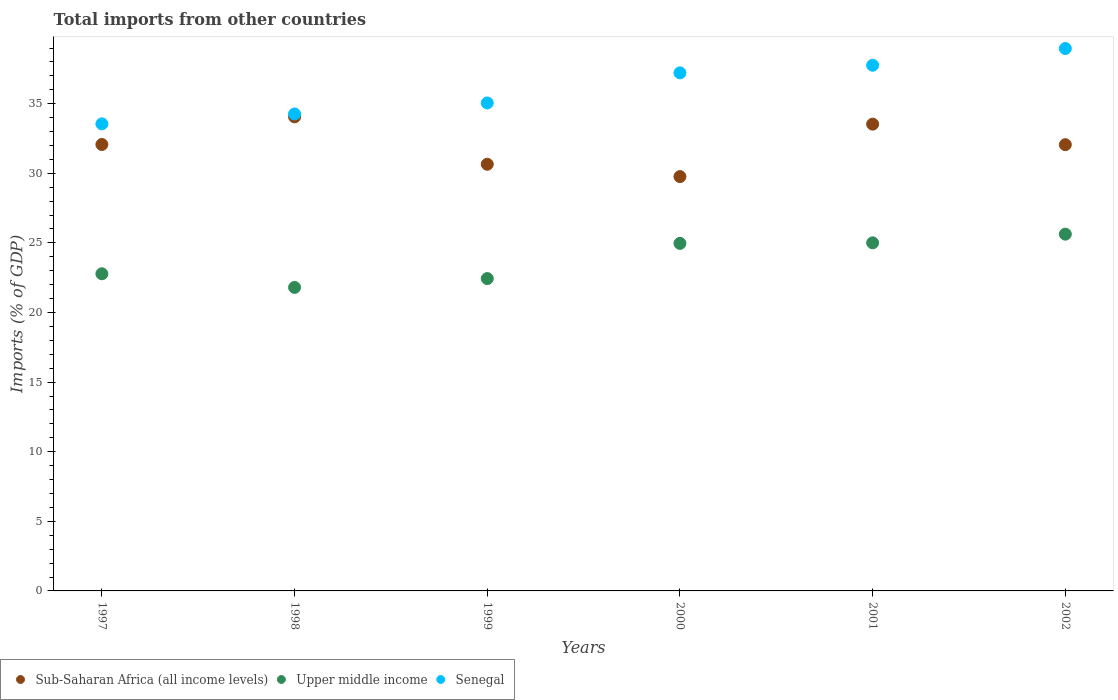How many different coloured dotlines are there?
Offer a terse response. 3. What is the total imports in Upper middle income in 1999?
Your response must be concise. 22.44. Across all years, what is the maximum total imports in Senegal?
Make the answer very short. 38.97. Across all years, what is the minimum total imports in Sub-Saharan Africa (all income levels)?
Provide a succinct answer. 29.77. In which year was the total imports in Senegal maximum?
Your response must be concise. 2002. In which year was the total imports in Upper middle income minimum?
Provide a short and direct response. 1998. What is the total total imports in Senegal in the graph?
Your answer should be very brief. 216.81. What is the difference between the total imports in Senegal in 1999 and that in 2001?
Your answer should be very brief. -2.71. What is the difference between the total imports in Upper middle income in 1998 and the total imports in Sub-Saharan Africa (all income levels) in 1999?
Keep it short and to the point. -8.85. What is the average total imports in Senegal per year?
Give a very brief answer. 36.14. In the year 2000, what is the difference between the total imports in Upper middle income and total imports in Sub-Saharan Africa (all income levels)?
Give a very brief answer. -4.8. What is the ratio of the total imports in Upper middle income in 1997 to that in 2000?
Offer a very short reply. 0.91. Is the difference between the total imports in Upper middle income in 2000 and 2001 greater than the difference between the total imports in Sub-Saharan Africa (all income levels) in 2000 and 2001?
Provide a short and direct response. Yes. What is the difference between the highest and the second highest total imports in Sub-Saharan Africa (all income levels)?
Provide a short and direct response. 0.52. What is the difference between the highest and the lowest total imports in Sub-Saharan Africa (all income levels)?
Make the answer very short. 4.29. Is it the case that in every year, the sum of the total imports in Senegal and total imports in Upper middle income  is greater than the total imports in Sub-Saharan Africa (all income levels)?
Keep it short and to the point. Yes. Does the total imports in Sub-Saharan Africa (all income levels) monotonically increase over the years?
Give a very brief answer. No. How many years are there in the graph?
Your response must be concise. 6. What is the difference between two consecutive major ticks on the Y-axis?
Your answer should be very brief. 5. How many legend labels are there?
Provide a succinct answer. 3. How are the legend labels stacked?
Your response must be concise. Horizontal. What is the title of the graph?
Give a very brief answer. Total imports from other countries. What is the label or title of the Y-axis?
Keep it short and to the point. Imports (% of GDP). What is the Imports (% of GDP) of Sub-Saharan Africa (all income levels) in 1997?
Your answer should be compact. 32.07. What is the Imports (% of GDP) in Upper middle income in 1997?
Give a very brief answer. 22.78. What is the Imports (% of GDP) of Senegal in 1997?
Make the answer very short. 33.55. What is the Imports (% of GDP) of Sub-Saharan Africa (all income levels) in 1998?
Your answer should be very brief. 34.06. What is the Imports (% of GDP) in Upper middle income in 1998?
Ensure brevity in your answer.  21.8. What is the Imports (% of GDP) in Senegal in 1998?
Offer a terse response. 34.26. What is the Imports (% of GDP) of Sub-Saharan Africa (all income levels) in 1999?
Keep it short and to the point. 30.65. What is the Imports (% of GDP) in Upper middle income in 1999?
Keep it short and to the point. 22.44. What is the Imports (% of GDP) in Senegal in 1999?
Provide a succinct answer. 35.05. What is the Imports (% of GDP) of Sub-Saharan Africa (all income levels) in 2000?
Your answer should be very brief. 29.77. What is the Imports (% of GDP) in Upper middle income in 2000?
Provide a short and direct response. 24.97. What is the Imports (% of GDP) of Senegal in 2000?
Give a very brief answer. 37.22. What is the Imports (% of GDP) of Sub-Saharan Africa (all income levels) in 2001?
Offer a terse response. 33.53. What is the Imports (% of GDP) in Upper middle income in 2001?
Offer a very short reply. 25.01. What is the Imports (% of GDP) in Senegal in 2001?
Provide a succinct answer. 37.76. What is the Imports (% of GDP) in Sub-Saharan Africa (all income levels) in 2002?
Keep it short and to the point. 32.06. What is the Imports (% of GDP) in Upper middle income in 2002?
Make the answer very short. 25.63. What is the Imports (% of GDP) in Senegal in 2002?
Make the answer very short. 38.97. Across all years, what is the maximum Imports (% of GDP) of Sub-Saharan Africa (all income levels)?
Offer a very short reply. 34.06. Across all years, what is the maximum Imports (% of GDP) of Upper middle income?
Provide a short and direct response. 25.63. Across all years, what is the maximum Imports (% of GDP) in Senegal?
Provide a short and direct response. 38.97. Across all years, what is the minimum Imports (% of GDP) in Sub-Saharan Africa (all income levels)?
Keep it short and to the point. 29.77. Across all years, what is the minimum Imports (% of GDP) of Upper middle income?
Provide a succinct answer. 21.8. Across all years, what is the minimum Imports (% of GDP) of Senegal?
Provide a short and direct response. 33.55. What is the total Imports (% of GDP) of Sub-Saharan Africa (all income levels) in the graph?
Provide a succinct answer. 192.13. What is the total Imports (% of GDP) of Upper middle income in the graph?
Offer a very short reply. 142.63. What is the total Imports (% of GDP) of Senegal in the graph?
Your response must be concise. 216.81. What is the difference between the Imports (% of GDP) of Sub-Saharan Africa (all income levels) in 1997 and that in 1998?
Ensure brevity in your answer.  -1.98. What is the difference between the Imports (% of GDP) of Upper middle income in 1997 and that in 1998?
Offer a terse response. 0.98. What is the difference between the Imports (% of GDP) of Senegal in 1997 and that in 1998?
Give a very brief answer. -0.71. What is the difference between the Imports (% of GDP) in Sub-Saharan Africa (all income levels) in 1997 and that in 1999?
Your answer should be compact. 1.42. What is the difference between the Imports (% of GDP) of Upper middle income in 1997 and that in 1999?
Offer a terse response. 0.35. What is the difference between the Imports (% of GDP) in Senegal in 1997 and that in 1999?
Offer a very short reply. -1.5. What is the difference between the Imports (% of GDP) of Sub-Saharan Africa (all income levels) in 1997 and that in 2000?
Offer a terse response. 2.31. What is the difference between the Imports (% of GDP) of Upper middle income in 1997 and that in 2000?
Your answer should be very brief. -2.18. What is the difference between the Imports (% of GDP) of Senegal in 1997 and that in 2000?
Your answer should be very brief. -3.66. What is the difference between the Imports (% of GDP) in Sub-Saharan Africa (all income levels) in 1997 and that in 2001?
Your answer should be compact. -1.46. What is the difference between the Imports (% of GDP) of Upper middle income in 1997 and that in 2001?
Offer a very short reply. -2.22. What is the difference between the Imports (% of GDP) in Senegal in 1997 and that in 2001?
Keep it short and to the point. -4.21. What is the difference between the Imports (% of GDP) in Sub-Saharan Africa (all income levels) in 1997 and that in 2002?
Keep it short and to the point. 0.01. What is the difference between the Imports (% of GDP) of Upper middle income in 1997 and that in 2002?
Ensure brevity in your answer.  -2.85. What is the difference between the Imports (% of GDP) in Senegal in 1997 and that in 2002?
Your answer should be compact. -5.41. What is the difference between the Imports (% of GDP) of Sub-Saharan Africa (all income levels) in 1998 and that in 1999?
Keep it short and to the point. 3.4. What is the difference between the Imports (% of GDP) of Upper middle income in 1998 and that in 1999?
Your response must be concise. -0.64. What is the difference between the Imports (% of GDP) of Senegal in 1998 and that in 1999?
Make the answer very short. -0.79. What is the difference between the Imports (% of GDP) of Sub-Saharan Africa (all income levels) in 1998 and that in 2000?
Make the answer very short. 4.29. What is the difference between the Imports (% of GDP) of Upper middle income in 1998 and that in 2000?
Provide a succinct answer. -3.16. What is the difference between the Imports (% of GDP) of Senegal in 1998 and that in 2000?
Provide a short and direct response. -2.95. What is the difference between the Imports (% of GDP) of Sub-Saharan Africa (all income levels) in 1998 and that in 2001?
Your answer should be compact. 0.52. What is the difference between the Imports (% of GDP) of Upper middle income in 1998 and that in 2001?
Provide a succinct answer. -3.2. What is the difference between the Imports (% of GDP) of Senegal in 1998 and that in 2001?
Offer a very short reply. -3.5. What is the difference between the Imports (% of GDP) in Sub-Saharan Africa (all income levels) in 1998 and that in 2002?
Your answer should be very brief. 2. What is the difference between the Imports (% of GDP) in Upper middle income in 1998 and that in 2002?
Give a very brief answer. -3.83. What is the difference between the Imports (% of GDP) of Senegal in 1998 and that in 2002?
Provide a short and direct response. -4.7. What is the difference between the Imports (% of GDP) in Sub-Saharan Africa (all income levels) in 1999 and that in 2000?
Give a very brief answer. 0.89. What is the difference between the Imports (% of GDP) in Upper middle income in 1999 and that in 2000?
Offer a very short reply. -2.53. What is the difference between the Imports (% of GDP) in Senegal in 1999 and that in 2000?
Ensure brevity in your answer.  -2.16. What is the difference between the Imports (% of GDP) in Sub-Saharan Africa (all income levels) in 1999 and that in 2001?
Your response must be concise. -2.88. What is the difference between the Imports (% of GDP) in Upper middle income in 1999 and that in 2001?
Give a very brief answer. -2.57. What is the difference between the Imports (% of GDP) in Senegal in 1999 and that in 2001?
Provide a succinct answer. -2.71. What is the difference between the Imports (% of GDP) in Sub-Saharan Africa (all income levels) in 1999 and that in 2002?
Offer a terse response. -1.41. What is the difference between the Imports (% of GDP) in Upper middle income in 1999 and that in 2002?
Your answer should be very brief. -3.19. What is the difference between the Imports (% of GDP) of Senegal in 1999 and that in 2002?
Your answer should be compact. -3.91. What is the difference between the Imports (% of GDP) of Sub-Saharan Africa (all income levels) in 2000 and that in 2001?
Make the answer very short. -3.77. What is the difference between the Imports (% of GDP) of Upper middle income in 2000 and that in 2001?
Keep it short and to the point. -0.04. What is the difference between the Imports (% of GDP) in Senegal in 2000 and that in 2001?
Provide a short and direct response. -0.55. What is the difference between the Imports (% of GDP) in Sub-Saharan Africa (all income levels) in 2000 and that in 2002?
Your answer should be very brief. -2.29. What is the difference between the Imports (% of GDP) of Upper middle income in 2000 and that in 2002?
Provide a succinct answer. -0.66. What is the difference between the Imports (% of GDP) in Senegal in 2000 and that in 2002?
Ensure brevity in your answer.  -1.75. What is the difference between the Imports (% of GDP) of Sub-Saharan Africa (all income levels) in 2001 and that in 2002?
Keep it short and to the point. 1.48. What is the difference between the Imports (% of GDP) of Upper middle income in 2001 and that in 2002?
Give a very brief answer. -0.62. What is the difference between the Imports (% of GDP) of Senegal in 2001 and that in 2002?
Your answer should be very brief. -1.2. What is the difference between the Imports (% of GDP) of Sub-Saharan Africa (all income levels) in 1997 and the Imports (% of GDP) of Upper middle income in 1998?
Make the answer very short. 10.27. What is the difference between the Imports (% of GDP) in Sub-Saharan Africa (all income levels) in 1997 and the Imports (% of GDP) in Senegal in 1998?
Ensure brevity in your answer.  -2.19. What is the difference between the Imports (% of GDP) of Upper middle income in 1997 and the Imports (% of GDP) of Senegal in 1998?
Your response must be concise. -11.48. What is the difference between the Imports (% of GDP) of Sub-Saharan Africa (all income levels) in 1997 and the Imports (% of GDP) of Upper middle income in 1999?
Keep it short and to the point. 9.63. What is the difference between the Imports (% of GDP) in Sub-Saharan Africa (all income levels) in 1997 and the Imports (% of GDP) in Senegal in 1999?
Offer a very short reply. -2.98. What is the difference between the Imports (% of GDP) in Upper middle income in 1997 and the Imports (% of GDP) in Senegal in 1999?
Your response must be concise. -12.27. What is the difference between the Imports (% of GDP) in Sub-Saharan Africa (all income levels) in 1997 and the Imports (% of GDP) in Upper middle income in 2000?
Make the answer very short. 7.11. What is the difference between the Imports (% of GDP) of Sub-Saharan Africa (all income levels) in 1997 and the Imports (% of GDP) of Senegal in 2000?
Give a very brief answer. -5.15. What is the difference between the Imports (% of GDP) of Upper middle income in 1997 and the Imports (% of GDP) of Senegal in 2000?
Your answer should be very brief. -14.43. What is the difference between the Imports (% of GDP) in Sub-Saharan Africa (all income levels) in 1997 and the Imports (% of GDP) in Upper middle income in 2001?
Provide a succinct answer. 7.07. What is the difference between the Imports (% of GDP) in Sub-Saharan Africa (all income levels) in 1997 and the Imports (% of GDP) in Senegal in 2001?
Your answer should be very brief. -5.69. What is the difference between the Imports (% of GDP) of Upper middle income in 1997 and the Imports (% of GDP) of Senegal in 2001?
Make the answer very short. -14.98. What is the difference between the Imports (% of GDP) in Sub-Saharan Africa (all income levels) in 1997 and the Imports (% of GDP) in Upper middle income in 2002?
Your response must be concise. 6.44. What is the difference between the Imports (% of GDP) of Sub-Saharan Africa (all income levels) in 1997 and the Imports (% of GDP) of Senegal in 2002?
Offer a terse response. -6.89. What is the difference between the Imports (% of GDP) in Upper middle income in 1997 and the Imports (% of GDP) in Senegal in 2002?
Your answer should be compact. -16.18. What is the difference between the Imports (% of GDP) of Sub-Saharan Africa (all income levels) in 1998 and the Imports (% of GDP) of Upper middle income in 1999?
Provide a succinct answer. 11.62. What is the difference between the Imports (% of GDP) of Sub-Saharan Africa (all income levels) in 1998 and the Imports (% of GDP) of Senegal in 1999?
Make the answer very short. -1. What is the difference between the Imports (% of GDP) of Upper middle income in 1998 and the Imports (% of GDP) of Senegal in 1999?
Keep it short and to the point. -13.25. What is the difference between the Imports (% of GDP) of Sub-Saharan Africa (all income levels) in 1998 and the Imports (% of GDP) of Upper middle income in 2000?
Your answer should be compact. 9.09. What is the difference between the Imports (% of GDP) of Sub-Saharan Africa (all income levels) in 1998 and the Imports (% of GDP) of Senegal in 2000?
Ensure brevity in your answer.  -3.16. What is the difference between the Imports (% of GDP) of Upper middle income in 1998 and the Imports (% of GDP) of Senegal in 2000?
Your response must be concise. -15.41. What is the difference between the Imports (% of GDP) of Sub-Saharan Africa (all income levels) in 1998 and the Imports (% of GDP) of Upper middle income in 2001?
Your answer should be very brief. 9.05. What is the difference between the Imports (% of GDP) of Sub-Saharan Africa (all income levels) in 1998 and the Imports (% of GDP) of Senegal in 2001?
Keep it short and to the point. -3.71. What is the difference between the Imports (% of GDP) of Upper middle income in 1998 and the Imports (% of GDP) of Senegal in 2001?
Your answer should be compact. -15.96. What is the difference between the Imports (% of GDP) in Sub-Saharan Africa (all income levels) in 1998 and the Imports (% of GDP) in Upper middle income in 2002?
Provide a short and direct response. 8.43. What is the difference between the Imports (% of GDP) of Sub-Saharan Africa (all income levels) in 1998 and the Imports (% of GDP) of Senegal in 2002?
Keep it short and to the point. -4.91. What is the difference between the Imports (% of GDP) of Upper middle income in 1998 and the Imports (% of GDP) of Senegal in 2002?
Your answer should be compact. -17.16. What is the difference between the Imports (% of GDP) of Sub-Saharan Africa (all income levels) in 1999 and the Imports (% of GDP) of Upper middle income in 2000?
Your answer should be compact. 5.68. What is the difference between the Imports (% of GDP) of Sub-Saharan Africa (all income levels) in 1999 and the Imports (% of GDP) of Senegal in 2000?
Ensure brevity in your answer.  -6.57. What is the difference between the Imports (% of GDP) of Upper middle income in 1999 and the Imports (% of GDP) of Senegal in 2000?
Ensure brevity in your answer.  -14.78. What is the difference between the Imports (% of GDP) of Sub-Saharan Africa (all income levels) in 1999 and the Imports (% of GDP) of Upper middle income in 2001?
Your answer should be very brief. 5.65. What is the difference between the Imports (% of GDP) in Sub-Saharan Africa (all income levels) in 1999 and the Imports (% of GDP) in Senegal in 2001?
Give a very brief answer. -7.11. What is the difference between the Imports (% of GDP) in Upper middle income in 1999 and the Imports (% of GDP) in Senegal in 2001?
Provide a succinct answer. -15.33. What is the difference between the Imports (% of GDP) of Sub-Saharan Africa (all income levels) in 1999 and the Imports (% of GDP) of Upper middle income in 2002?
Your answer should be very brief. 5.02. What is the difference between the Imports (% of GDP) of Sub-Saharan Africa (all income levels) in 1999 and the Imports (% of GDP) of Senegal in 2002?
Give a very brief answer. -8.31. What is the difference between the Imports (% of GDP) of Upper middle income in 1999 and the Imports (% of GDP) of Senegal in 2002?
Provide a succinct answer. -16.53. What is the difference between the Imports (% of GDP) of Sub-Saharan Africa (all income levels) in 2000 and the Imports (% of GDP) of Upper middle income in 2001?
Offer a very short reply. 4.76. What is the difference between the Imports (% of GDP) of Sub-Saharan Africa (all income levels) in 2000 and the Imports (% of GDP) of Senegal in 2001?
Offer a terse response. -8. What is the difference between the Imports (% of GDP) in Upper middle income in 2000 and the Imports (% of GDP) in Senegal in 2001?
Give a very brief answer. -12.8. What is the difference between the Imports (% of GDP) in Sub-Saharan Africa (all income levels) in 2000 and the Imports (% of GDP) in Upper middle income in 2002?
Provide a succinct answer. 4.13. What is the difference between the Imports (% of GDP) in Sub-Saharan Africa (all income levels) in 2000 and the Imports (% of GDP) in Senegal in 2002?
Make the answer very short. -9.2. What is the difference between the Imports (% of GDP) in Upper middle income in 2000 and the Imports (% of GDP) in Senegal in 2002?
Provide a succinct answer. -14. What is the difference between the Imports (% of GDP) of Sub-Saharan Africa (all income levels) in 2001 and the Imports (% of GDP) of Upper middle income in 2002?
Ensure brevity in your answer.  7.9. What is the difference between the Imports (% of GDP) in Sub-Saharan Africa (all income levels) in 2001 and the Imports (% of GDP) in Senegal in 2002?
Offer a very short reply. -5.43. What is the difference between the Imports (% of GDP) in Upper middle income in 2001 and the Imports (% of GDP) in Senegal in 2002?
Make the answer very short. -13.96. What is the average Imports (% of GDP) in Sub-Saharan Africa (all income levels) per year?
Give a very brief answer. 32.02. What is the average Imports (% of GDP) of Upper middle income per year?
Offer a very short reply. 23.77. What is the average Imports (% of GDP) in Senegal per year?
Provide a short and direct response. 36.14. In the year 1997, what is the difference between the Imports (% of GDP) of Sub-Saharan Africa (all income levels) and Imports (% of GDP) of Upper middle income?
Make the answer very short. 9.29. In the year 1997, what is the difference between the Imports (% of GDP) of Sub-Saharan Africa (all income levels) and Imports (% of GDP) of Senegal?
Your answer should be very brief. -1.48. In the year 1997, what is the difference between the Imports (% of GDP) in Upper middle income and Imports (% of GDP) in Senegal?
Your response must be concise. -10.77. In the year 1998, what is the difference between the Imports (% of GDP) in Sub-Saharan Africa (all income levels) and Imports (% of GDP) in Upper middle income?
Offer a terse response. 12.25. In the year 1998, what is the difference between the Imports (% of GDP) of Sub-Saharan Africa (all income levels) and Imports (% of GDP) of Senegal?
Give a very brief answer. -0.21. In the year 1998, what is the difference between the Imports (% of GDP) in Upper middle income and Imports (% of GDP) in Senegal?
Your answer should be compact. -12.46. In the year 1999, what is the difference between the Imports (% of GDP) of Sub-Saharan Africa (all income levels) and Imports (% of GDP) of Upper middle income?
Provide a short and direct response. 8.21. In the year 1999, what is the difference between the Imports (% of GDP) of Sub-Saharan Africa (all income levels) and Imports (% of GDP) of Senegal?
Offer a very short reply. -4.4. In the year 1999, what is the difference between the Imports (% of GDP) of Upper middle income and Imports (% of GDP) of Senegal?
Offer a very short reply. -12.62. In the year 2000, what is the difference between the Imports (% of GDP) in Sub-Saharan Africa (all income levels) and Imports (% of GDP) in Upper middle income?
Provide a succinct answer. 4.8. In the year 2000, what is the difference between the Imports (% of GDP) of Sub-Saharan Africa (all income levels) and Imports (% of GDP) of Senegal?
Offer a very short reply. -7.45. In the year 2000, what is the difference between the Imports (% of GDP) in Upper middle income and Imports (% of GDP) in Senegal?
Your answer should be very brief. -12.25. In the year 2001, what is the difference between the Imports (% of GDP) of Sub-Saharan Africa (all income levels) and Imports (% of GDP) of Upper middle income?
Ensure brevity in your answer.  8.53. In the year 2001, what is the difference between the Imports (% of GDP) in Sub-Saharan Africa (all income levels) and Imports (% of GDP) in Senegal?
Your answer should be very brief. -4.23. In the year 2001, what is the difference between the Imports (% of GDP) of Upper middle income and Imports (% of GDP) of Senegal?
Your response must be concise. -12.76. In the year 2002, what is the difference between the Imports (% of GDP) in Sub-Saharan Africa (all income levels) and Imports (% of GDP) in Upper middle income?
Make the answer very short. 6.43. In the year 2002, what is the difference between the Imports (% of GDP) in Sub-Saharan Africa (all income levels) and Imports (% of GDP) in Senegal?
Your answer should be very brief. -6.91. In the year 2002, what is the difference between the Imports (% of GDP) of Upper middle income and Imports (% of GDP) of Senegal?
Offer a terse response. -13.34. What is the ratio of the Imports (% of GDP) in Sub-Saharan Africa (all income levels) in 1997 to that in 1998?
Make the answer very short. 0.94. What is the ratio of the Imports (% of GDP) of Upper middle income in 1997 to that in 1998?
Offer a terse response. 1.04. What is the ratio of the Imports (% of GDP) in Senegal in 1997 to that in 1998?
Your answer should be very brief. 0.98. What is the ratio of the Imports (% of GDP) in Sub-Saharan Africa (all income levels) in 1997 to that in 1999?
Keep it short and to the point. 1.05. What is the ratio of the Imports (% of GDP) of Upper middle income in 1997 to that in 1999?
Keep it short and to the point. 1.02. What is the ratio of the Imports (% of GDP) of Senegal in 1997 to that in 1999?
Give a very brief answer. 0.96. What is the ratio of the Imports (% of GDP) of Sub-Saharan Africa (all income levels) in 1997 to that in 2000?
Your response must be concise. 1.08. What is the ratio of the Imports (% of GDP) in Upper middle income in 1997 to that in 2000?
Provide a short and direct response. 0.91. What is the ratio of the Imports (% of GDP) of Senegal in 1997 to that in 2000?
Offer a very short reply. 0.9. What is the ratio of the Imports (% of GDP) of Sub-Saharan Africa (all income levels) in 1997 to that in 2001?
Offer a terse response. 0.96. What is the ratio of the Imports (% of GDP) in Upper middle income in 1997 to that in 2001?
Ensure brevity in your answer.  0.91. What is the ratio of the Imports (% of GDP) in Senegal in 1997 to that in 2001?
Offer a very short reply. 0.89. What is the ratio of the Imports (% of GDP) in Sub-Saharan Africa (all income levels) in 1997 to that in 2002?
Your answer should be compact. 1. What is the ratio of the Imports (% of GDP) of Senegal in 1997 to that in 2002?
Make the answer very short. 0.86. What is the ratio of the Imports (% of GDP) of Sub-Saharan Africa (all income levels) in 1998 to that in 1999?
Your response must be concise. 1.11. What is the ratio of the Imports (% of GDP) of Upper middle income in 1998 to that in 1999?
Ensure brevity in your answer.  0.97. What is the ratio of the Imports (% of GDP) in Senegal in 1998 to that in 1999?
Offer a terse response. 0.98. What is the ratio of the Imports (% of GDP) in Sub-Saharan Africa (all income levels) in 1998 to that in 2000?
Provide a succinct answer. 1.14. What is the ratio of the Imports (% of GDP) in Upper middle income in 1998 to that in 2000?
Give a very brief answer. 0.87. What is the ratio of the Imports (% of GDP) of Senegal in 1998 to that in 2000?
Your response must be concise. 0.92. What is the ratio of the Imports (% of GDP) of Sub-Saharan Africa (all income levels) in 1998 to that in 2001?
Ensure brevity in your answer.  1.02. What is the ratio of the Imports (% of GDP) of Upper middle income in 1998 to that in 2001?
Offer a very short reply. 0.87. What is the ratio of the Imports (% of GDP) of Senegal in 1998 to that in 2001?
Ensure brevity in your answer.  0.91. What is the ratio of the Imports (% of GDP) in Sub-Saharan Africa (all income levels) in 1998 to that in 2002?
Make the answer very short. 1.06. What is the ratio of the Imports (% of GDP) in Upper middle income in 1998 to that in 2002?
Offer a terse response. 0.85. What is the ratio of the Imports (% of GDP) in Senegal in 1998 to that in 2002?
Your response must be concise. 0.88. What is the ratio of the Imports (% of GDP) of Sub-Saharan Africa (all income levels) in 1999 to that in 2000?
Give a very brief answer. 1.03. What is the ratio of the Imports (% of GDP) in Upper middle income in 1999 to that in 2000?
Keep it short and to the point. 0.9. What is the ratio of the Imports (% of GDP) in Senegal in 1999 to that in 2000?
Your answer should be very brief. 0.94. What is the ratio of the Imports (% of GDP) of Sub-Saharan Africa (all income levels) in 1999 to that in 2001?
Offer a terse response. 0.91. What is the ratio of the Imports (% of GDP) in Upper middle income in 1999 to that in 2001?
Your answer should be very brief. 0.9. What is the ratio of the Imports (% of GDP) in Senegal in 1999 to that in 2001?
Ensure brevity in your answer.  0.93. What is the ratio of the Imports (% of GDP) in Sub-Saharan Africa (all income levels) in 1999 to that in 2002?
Offer a very short reply. 0.96. What is the ratio of the Imports (% of GDP) of Upper middle income in 1999 to that in 2002?
Offer a terse response. 0.88. What is the ratio of the Imports (% of GDP) in Senegal in 1999 to that in 2002?
Your response must be concise. 0.9. What is the ratio of the Imports (% of GDP) in Sub-Saharan Africa (all income levels) in 2000 to that in 2001?
Ensure brevity in your answer.  0.89. What is the ratio of the Imports (% of GDP) of Senegal in 2000 to that in 2001?
Give a very brief answer. 0.99. What is the ratio of the Imports (% of GDP) in Sub-Saharan Africa (all income levels) in 2000 to that in 2002?
Make the answer very short. 0.93. What is the ratio of the Imports (% of GDP) in Upper middle income in 2000 to that in 2002?
Provide a short and direct response. 0.97. What is the ratio of the Imports (% of GDP) in Senegal in 2000 to that in 2002?
Give a very brief answer. 0.96. What is the ratio of the Imports (% of GDP) in Sub-Saharan Africa (all income levels) in 2001 to that in 2002?
Your response must be concise. 1.05. What is the ratio of the Imports (% of GDP) in Upper middle income in 2001 to that in 2002?
Ensure brevity in your answer.  0.98. What is the ratio of the Imports (% of GDP) in Senegal in 2001 to that in 2002?
Your answer should be very brief. 0.97. What is the difference between the highest and the second highest Imports (% of GDP) of Sub-Saharan Africa (all income levels)?
Provide a short and direct response. 0.52. What is the difference between the highest and the second highest Imports (% of GDP) in Upper middle income?
Your answer should be very brief. 0.62. What is the difference between the highest and the second highest Imports (% of GDP) of Senegal?
Ensure brevity in your answer.  1.2. What is the difference between the highest and the lowest Imports (% of GDP) of Sub-Saharan Africa (all income levels)?
Make the answer very short. 4.29. What is the difference between the highest and the lowest Imports (% of GDP) in Upper middle income?
Your answer should be compact. 3.83. What is the difference between the highest and the lowest Imports (% of GDP) of Senegal?
Your answer should be compact. 5.41. 